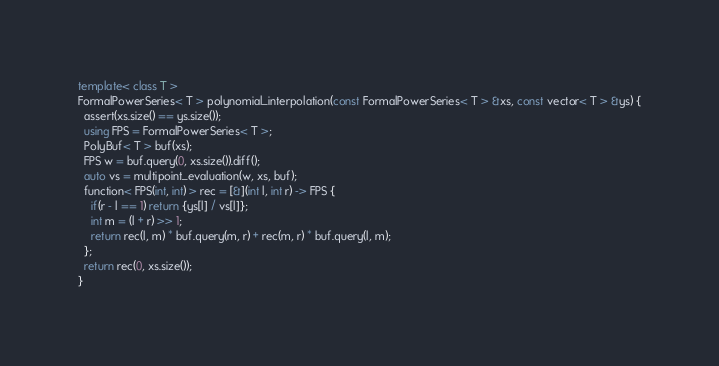<code> <loc_0><loc_0><loc_500><loc_500><_C++_>template< class T >
FormalPowerSeries< T > polynomial_interpolation(const FormalPowerSeries< T > &xs, const vector< T > &ys) {
  assert(xs.size() == ys.size());
  using FPS = FormalPowerSeries< T >;
  PolyBuf< T > buf(xs);
  FPS w = buf.query(0, xs.size()).diff();
  auto vs = multipoint_evaluation(w, xs, buf);
  function< FPS(int, int) > rec = [&](int l, int r) -> FPS {
    if(r - l == 1) return {ys[l] / vs[l]};
    int m = (l + r) >> 1;
    return rec(l, m) * buf.query(m, r) + rec(m, r) * buf.query(l, m);
  };
  return rec(0, xs.size());
}
</code> 